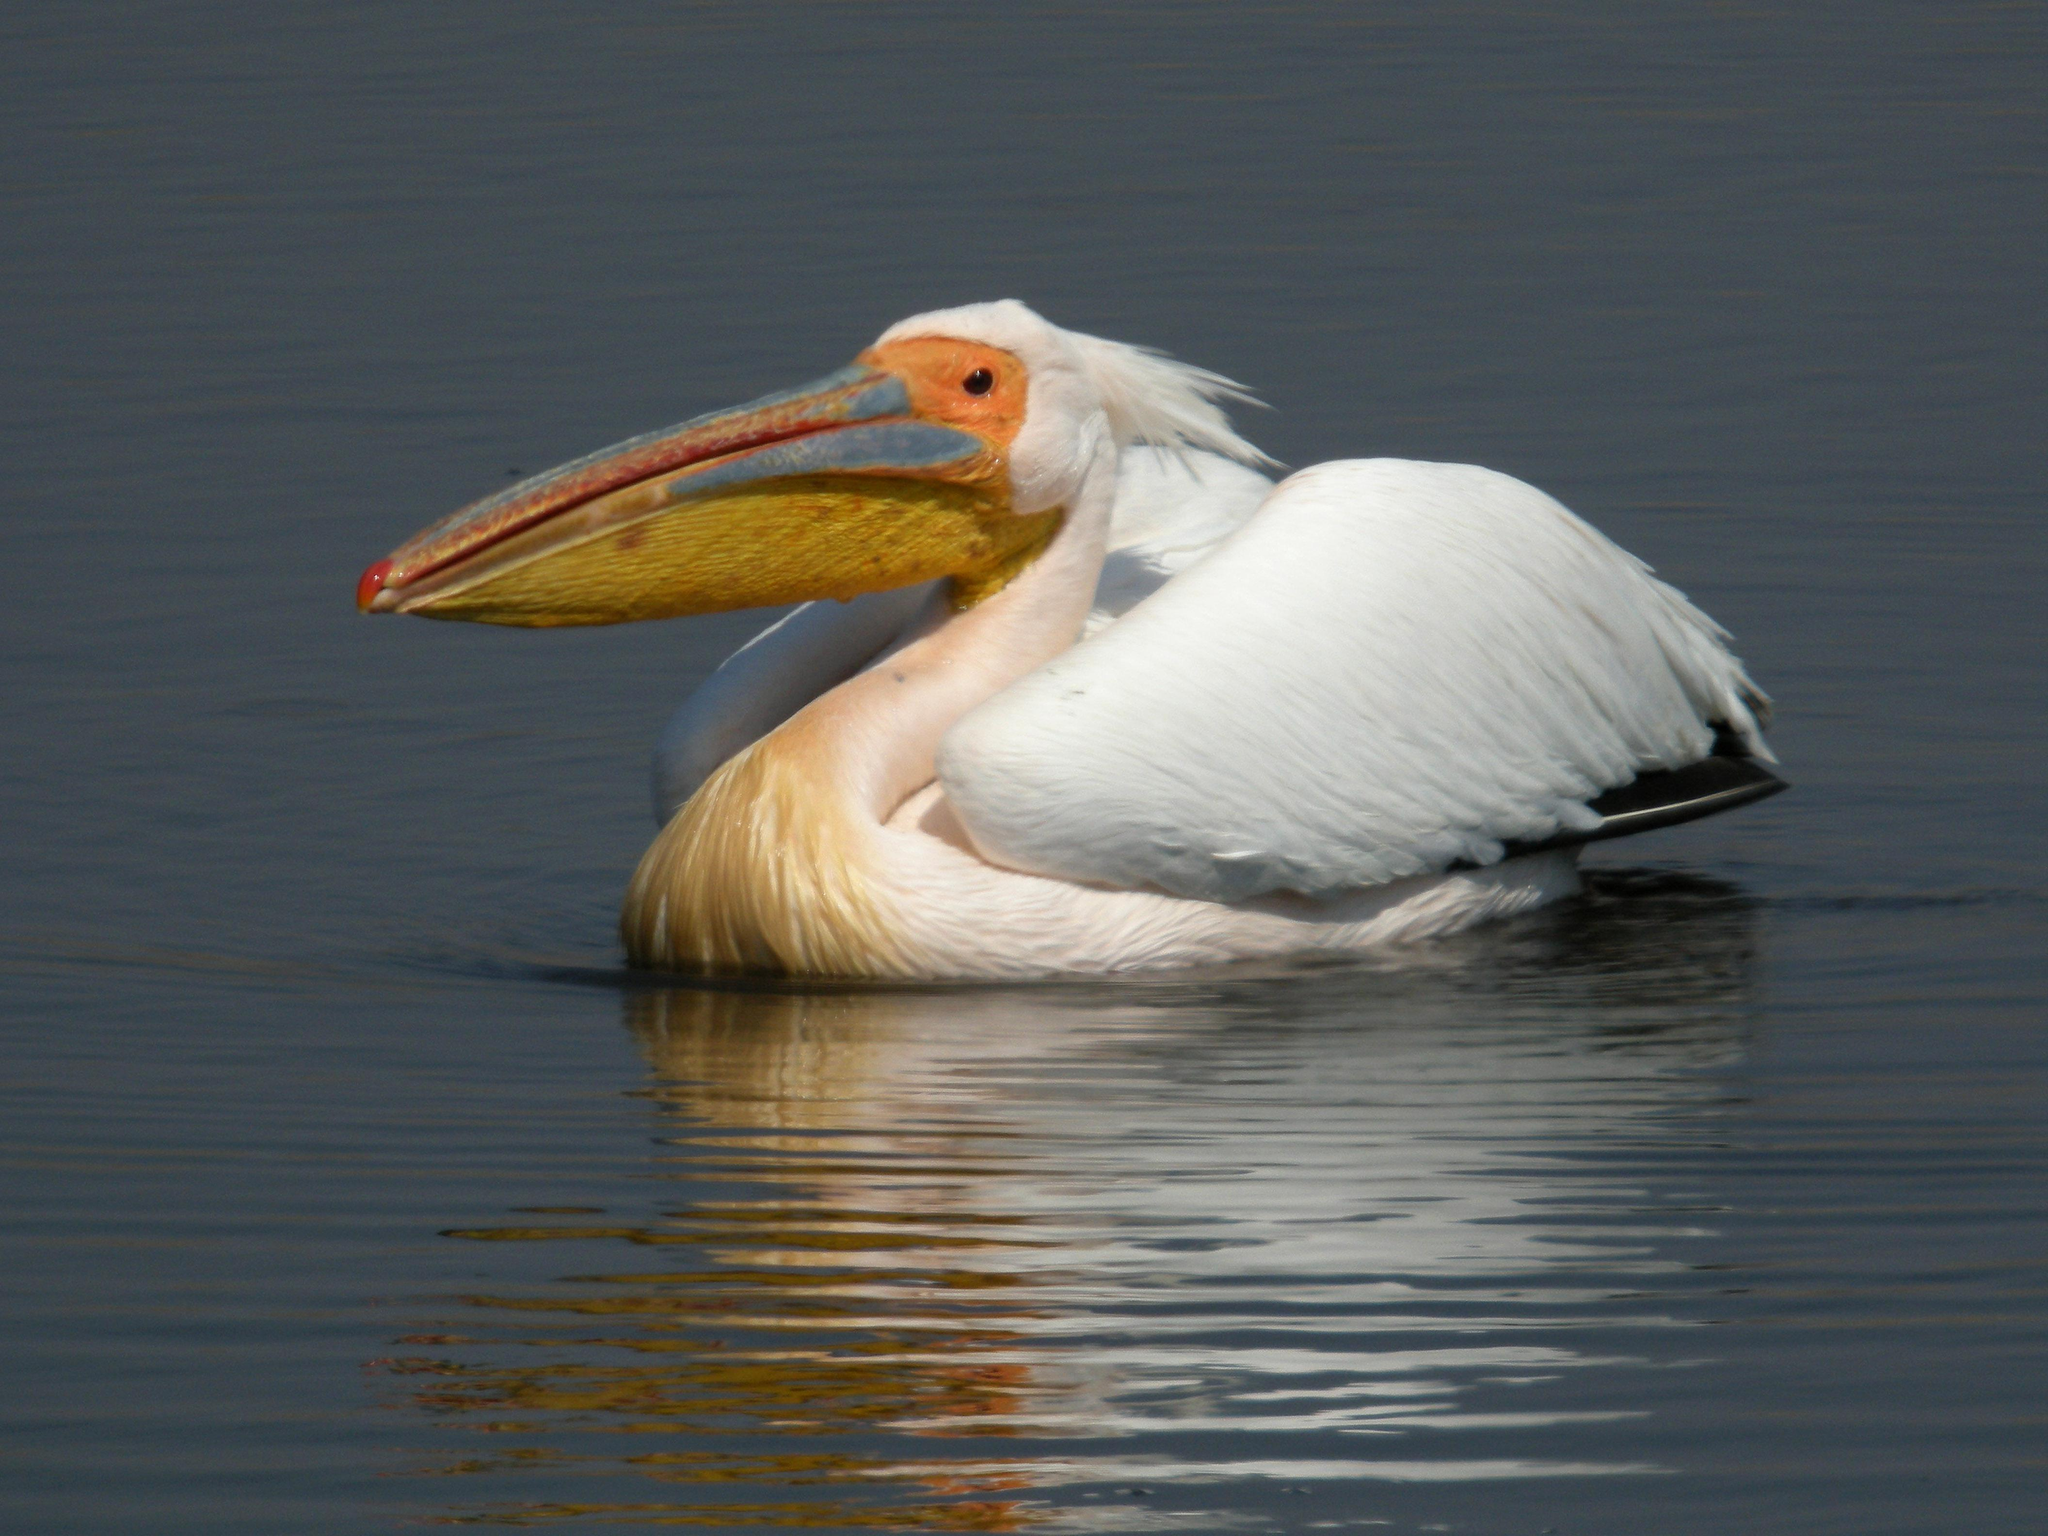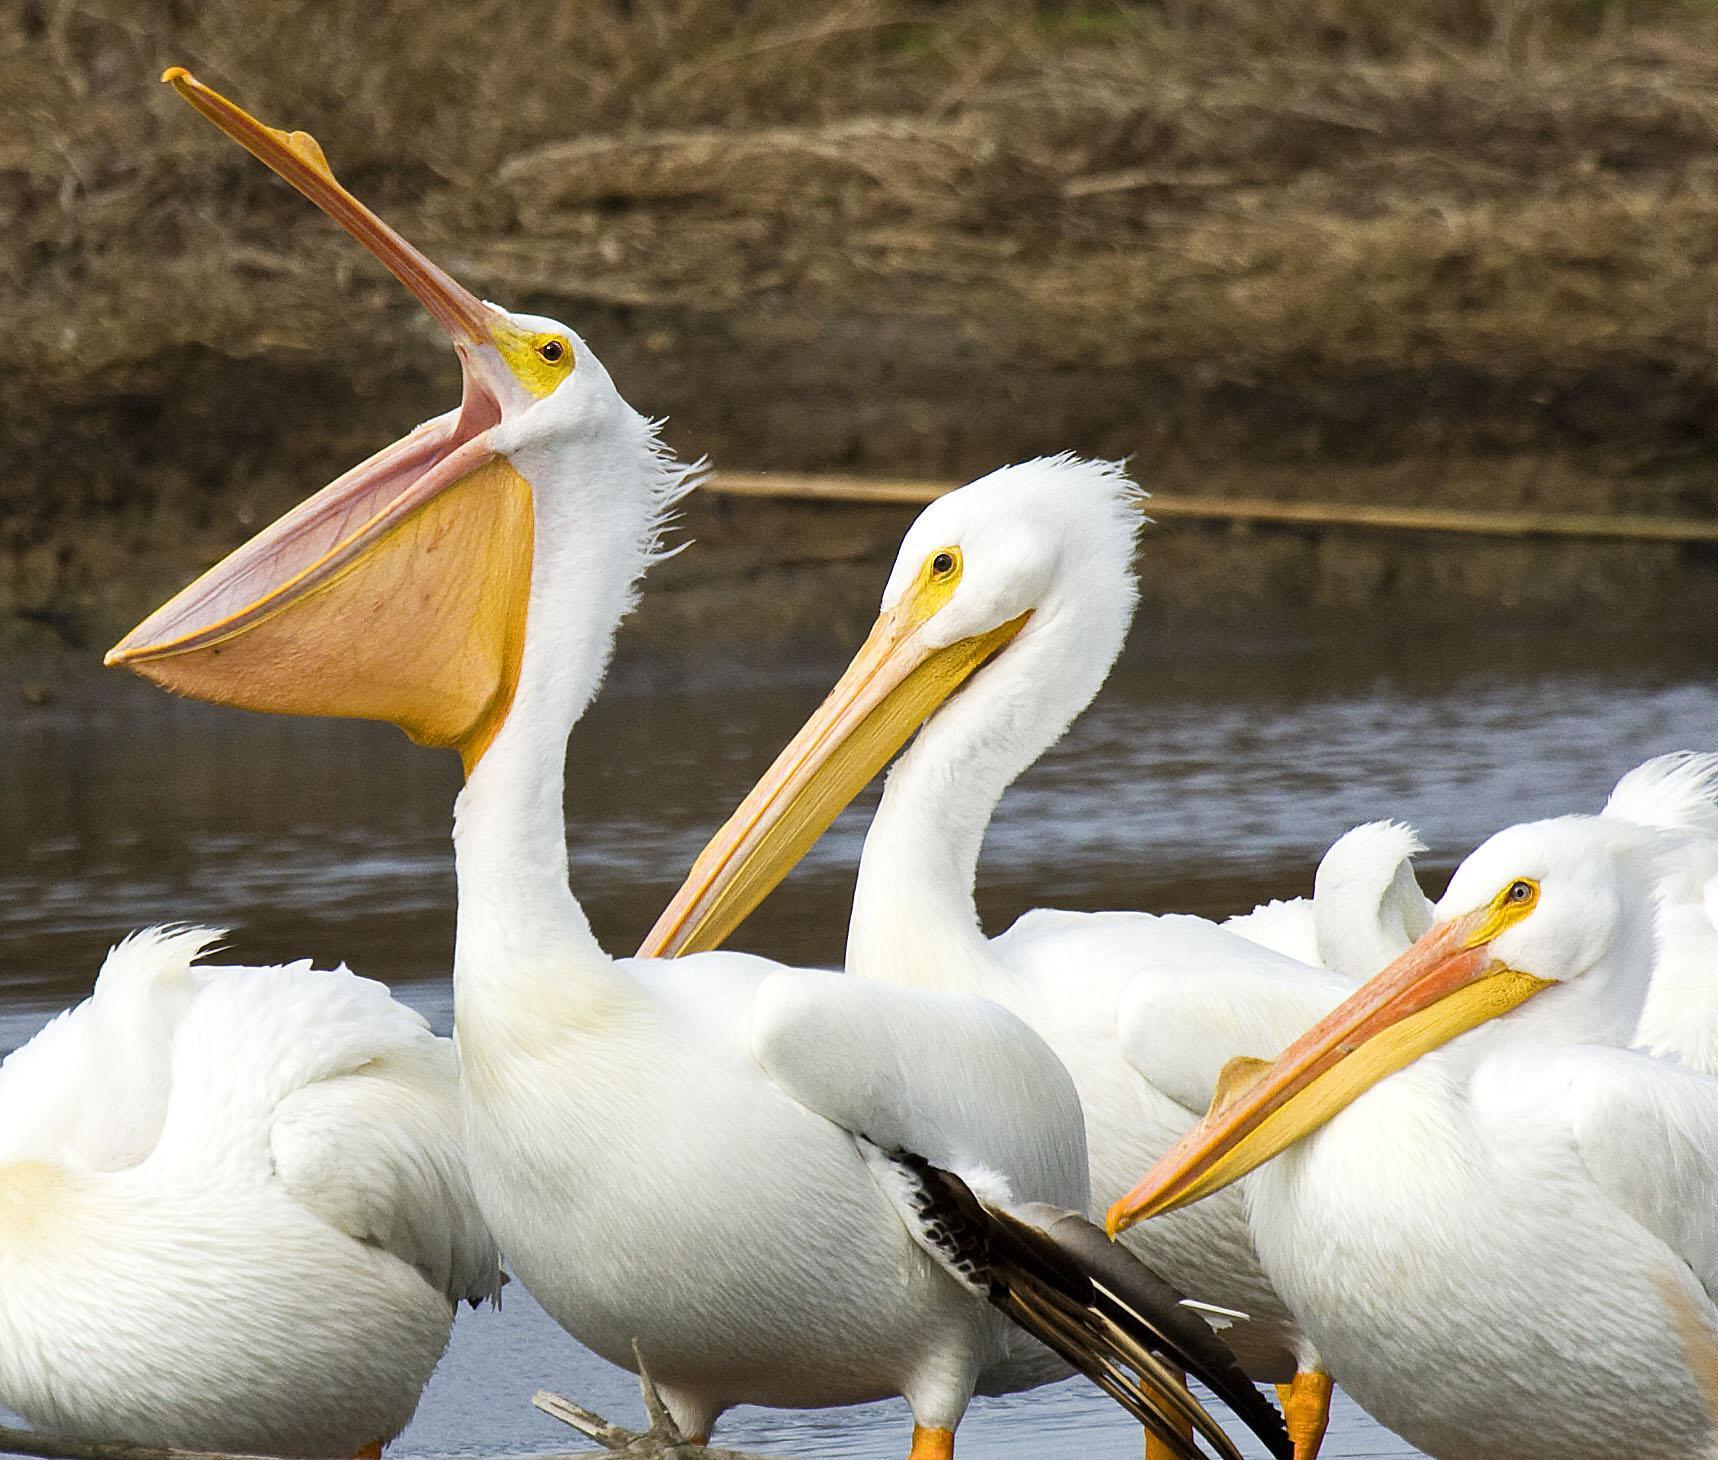The first image is the image on the left, the second image is the image on the right. Evaluate the accuracy of this statement regarding the images: "The bird in the left image that is furthest to the left is facing towards the left.". Is it true? Answer yes or no. Yes. 